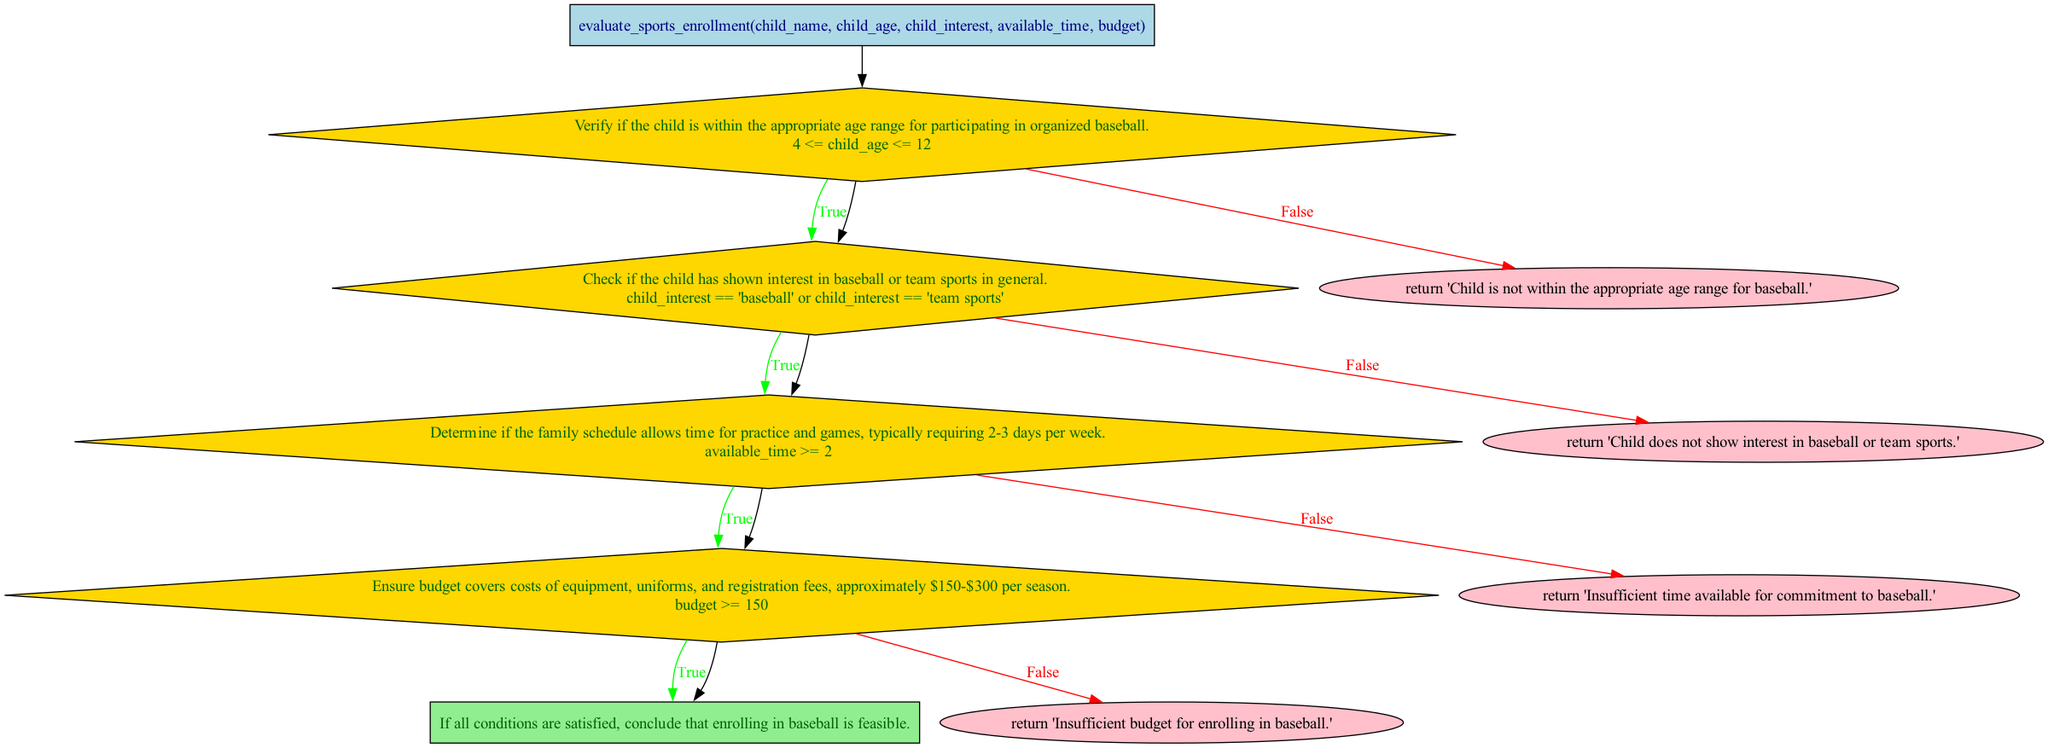What is the first step in the evaluation process? The first step in the evaluation process is checking age eligibility. This is the initial check to determine if the child meets the age requirements for participating in organized baseball.
Answer: check_age_eligibility How many total steps are there in the evaluation flow? By counting all the nodes in the diagram, a total of five steps can be identified in the evaluation process.
Answer: five What condition must be met for the time commitment step? The condition that must be met is that the available time must be at least two days per week, allowing for practice and games.
Answer: available time >= 2 What happens if the child's interest does not align with baseball or team sports? If the child's interest does not align, the flowchart indicates that the evaluation returns the message 'Child does not show interest in baseball or team sports.'
Answer: 'Child does not show interest in baseball or team sports.' What is the action taken if all conditions are satisfied? When all conditions are satisfied, the final evaluation concludes that enrolling in baseball is feasible and beneficial. This is the positive outcome of the evaluation process.
Answer: 'Enrolling in baseball is feasible and beneficial based on the evaluation.' 